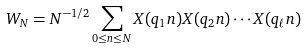Convert formula to latex. <formula><loc_0><loc_0><loc_500><loc_500>W _ { N } = N ^ { - 1 / 2 } \sum _ { 0 \leq n \leq N } X ( q _ { 1 } n ) X ( q _ { 2 } n ) \cdots X ( q _ { \ell } n )</formula> 